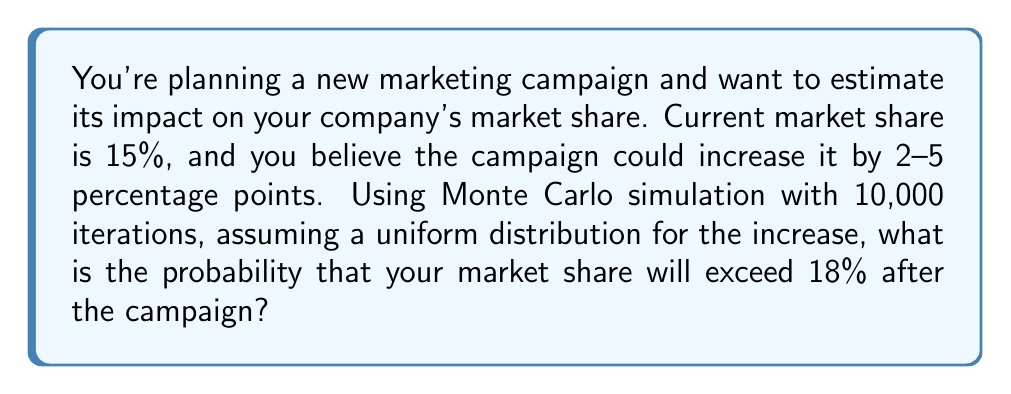Can you solve this math problem? To solve this problem using Monte Carlo simulation, we'll follow these steps:

1. Set up the simulation parameters:
   - Current market share: 15%
   - Potential increase: Uniformly distributed between 2% and 5%
   - Number of iterations: 10,000

2. For each iteration:
   a. Generate a random number $r$ between 0 and 1 using a uniform distribution.
   b. Calculate the market share increase: $increase = 2\% + (5\% - 2\%) \times r = 2\% + 3\% \times r$
   c. Calculate the new market share: $new\_share = 15\% + increase$
   d. Check if the new market share exceeds 18%

3. Count the number of times the new market share exceeds 18%.

4. Calculate the probability by dividing the count by the total number of iterations.

Let's implement this in Python:

```python
import random

iterations = 10000
count = 0

for _ in range(iterations):
    increase = 0.02 + 0.03 * random.random()
    new_share = 0.15 + increase
    if new_share > 0.18:
        count += 1

probability = count / iterations
```

The resulting probability will be approximately 0.6667, or 66.67%.

This means that based on the Monte Carlo simulation, there is about a 66.67% chance that your market share will exceed 18% after the marketing campaign.
Answer: 66.67% 